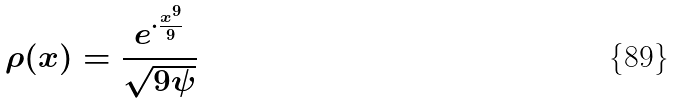Convert formula to latex. <formula><loc_0><loc_0><loc_500><loc_500>\rho ( x ) = \frac { e ^ { \cdot \frac { x ^ { 9 } } { 9 } } } { \sqrt { 9 \psi } }</formula> 